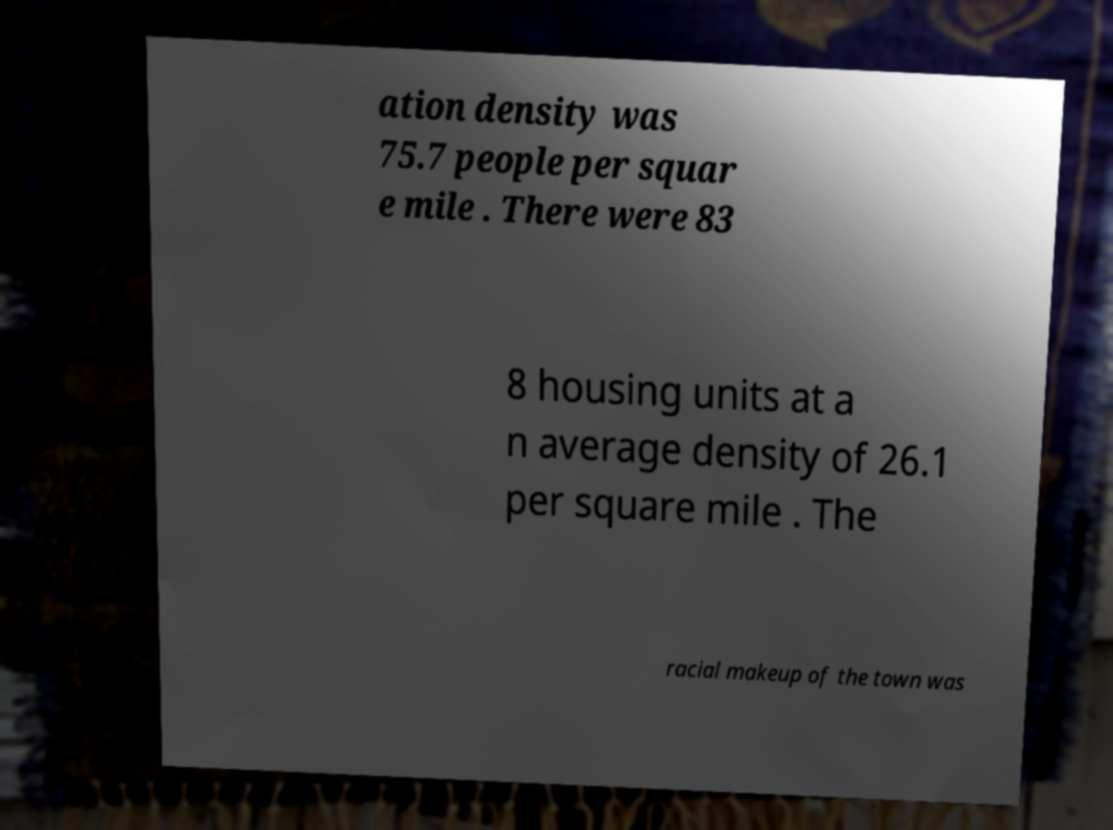What messages or text are displayed in this image? I need them in a readable, typed format. ation density was 75.7 people per squar e mile . There were 83 8 housing units at a n average density of 26.1 per square mile . The racial makeup of the town was 